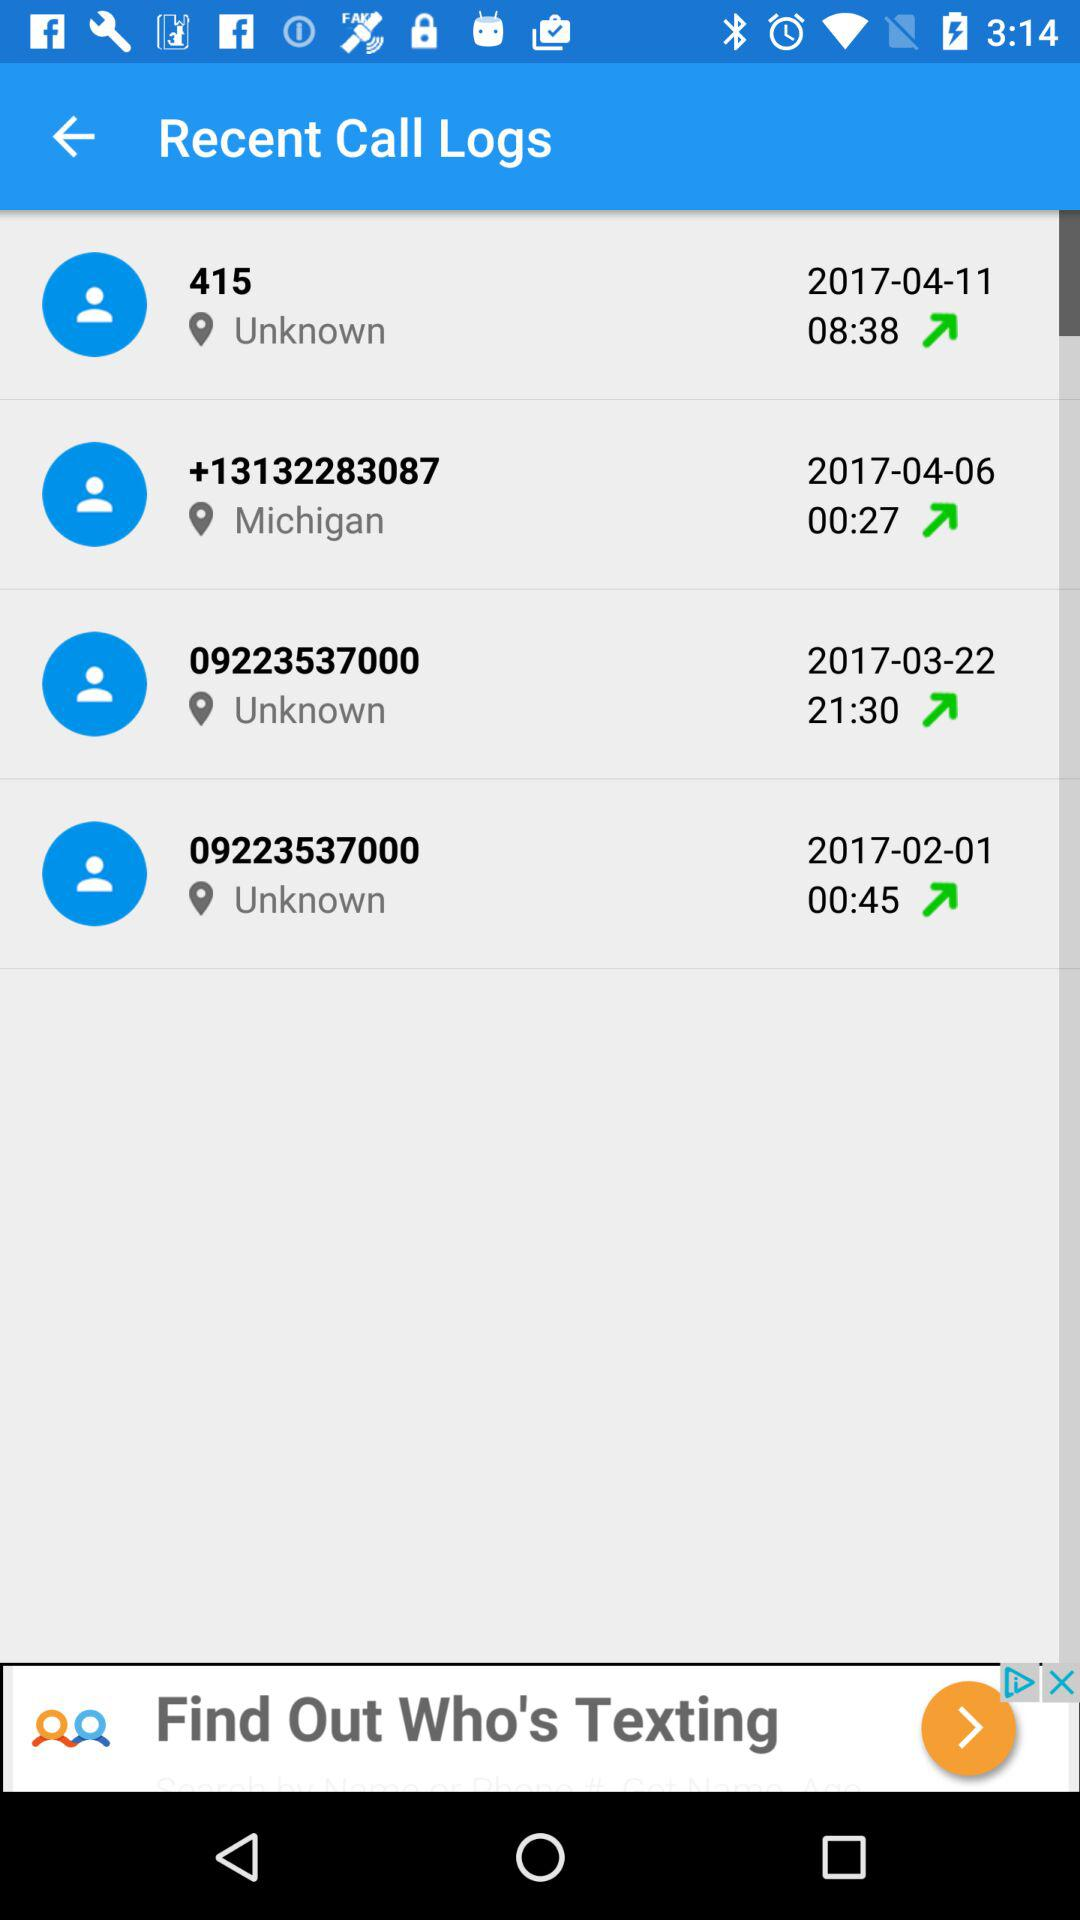Which number's location is Michigan? The number whose location is Michigan is +13132283087. 